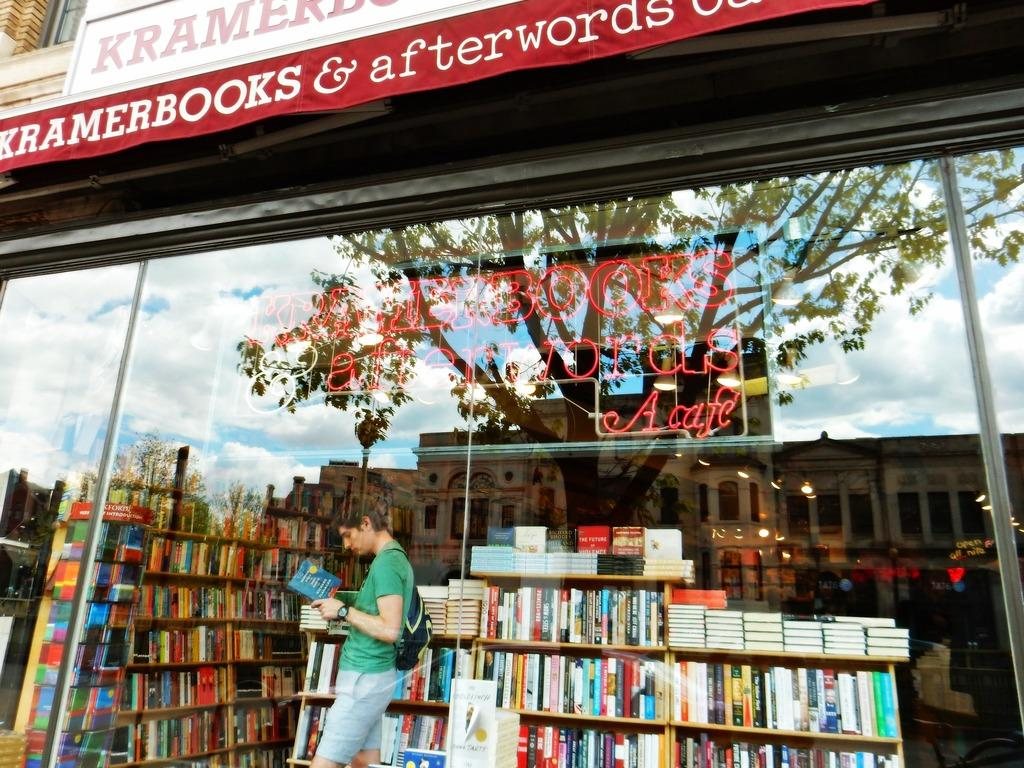<image>
Give a short and clear explanation of the subsequent image. A man in a green shirt reads a book standing next to a bookshelf at Kramerbooks & afterwords. 